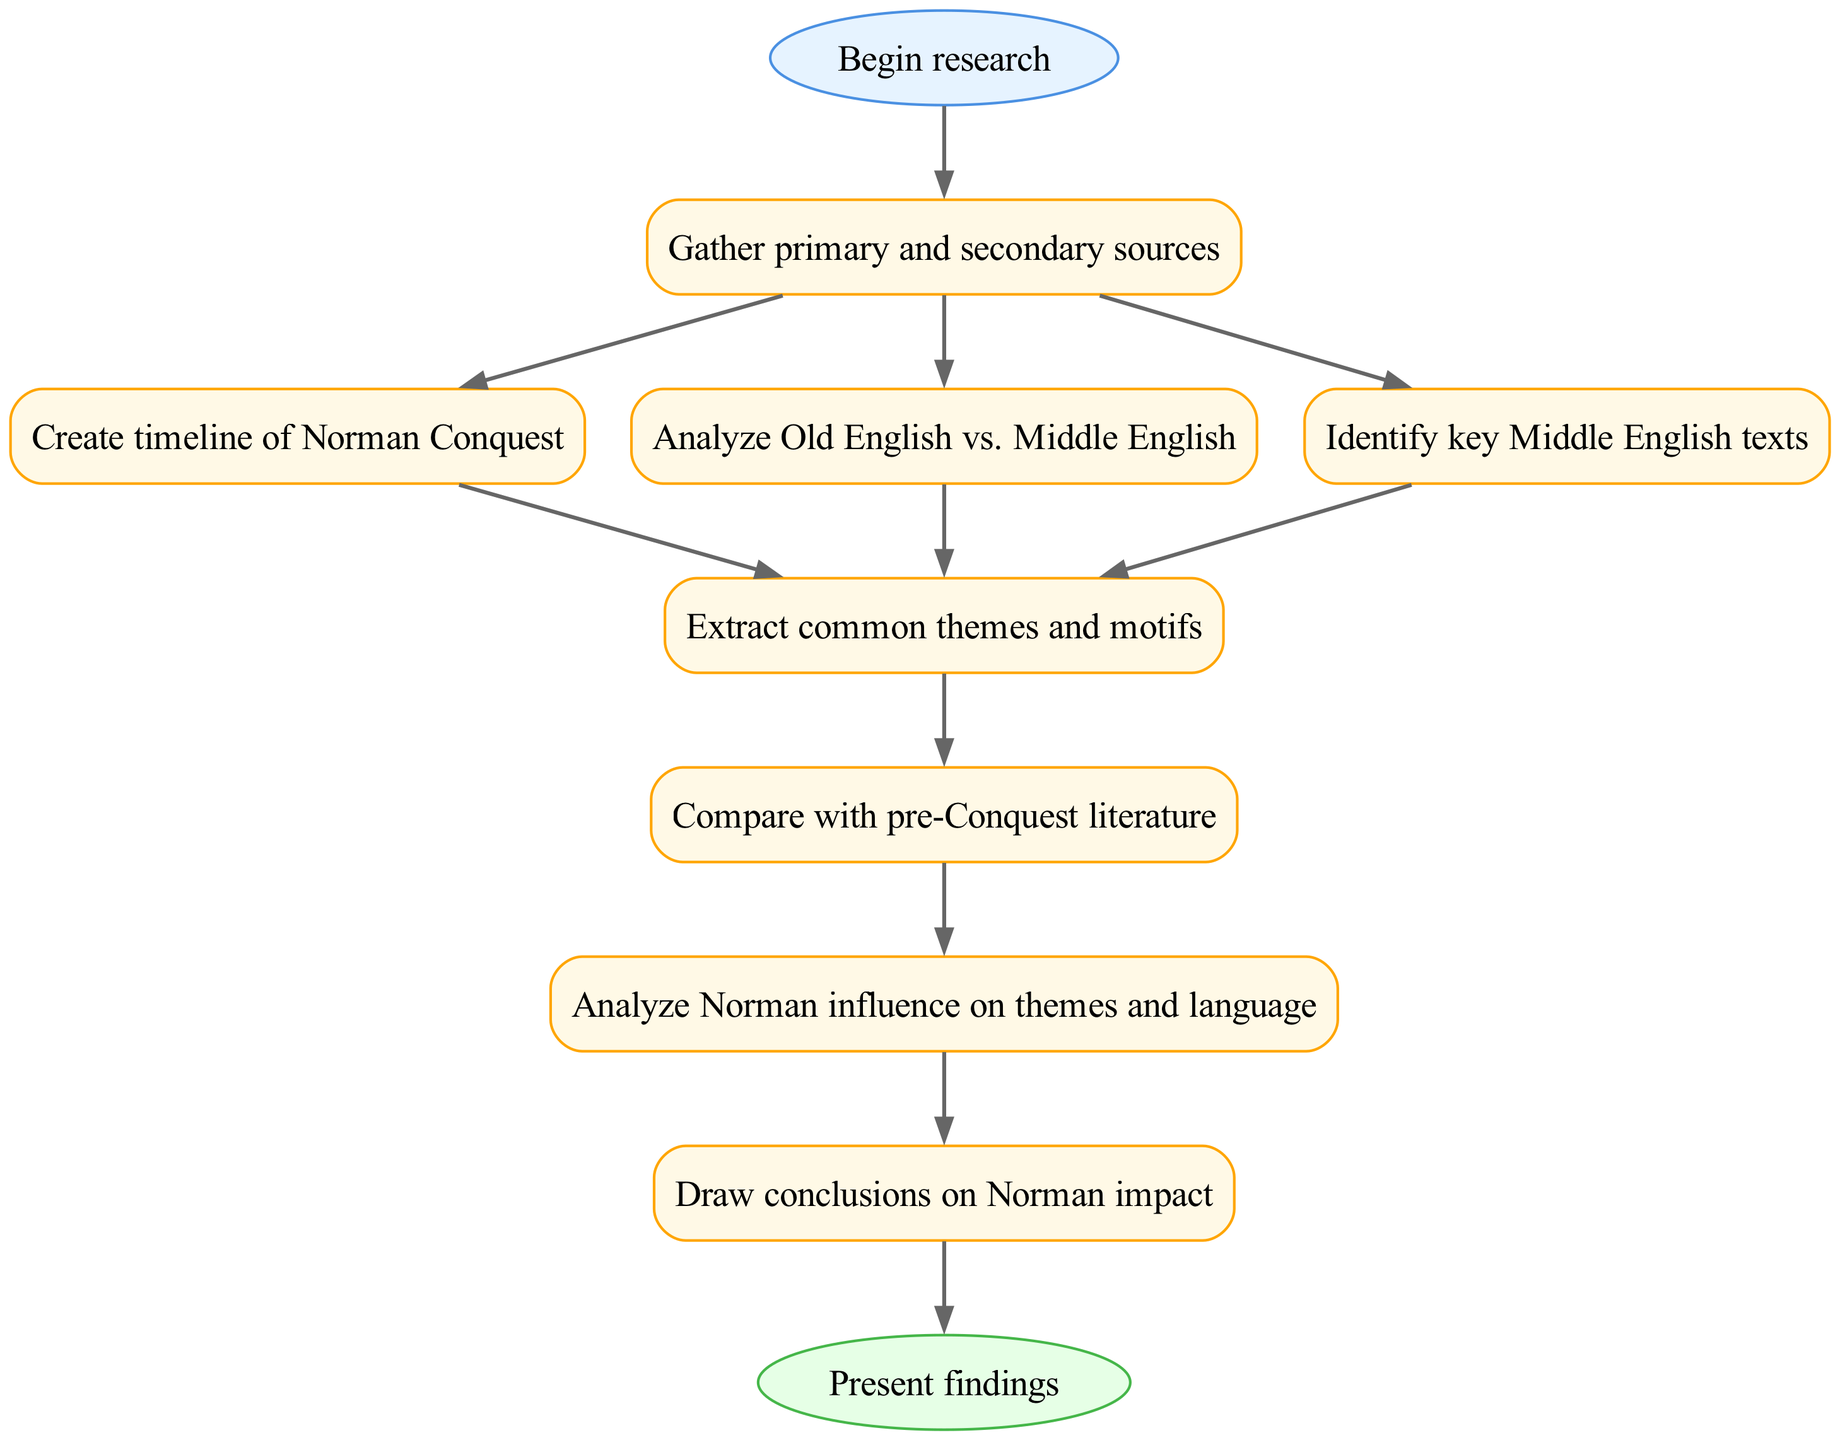What is the first step in the research workflow? The diagram indicates that the first step is labeled "Begin research."
Answer: Begin research How many nodes are there in total? By counting all the listed nodes from "Begin research" to "Present findings," there are 10 nodes present in the diagram.
Answer: 10 What is the last step in the research workflow? The last step shown in the diagram is "Present findings."
Answer: Present findings Which node follows "Analyze Norman influence on themes and language"? According to the flow described in the diagram, the node that follows "Analyze Norman influence on themes and language" is "Draw conclusions on Norman impact."
Answer: Draw conclusions on Norman impact How many edges connect to the "Gather primary and secondary sources" node? Examining the edges linked to the "Gather primary and secondary sources" node, there are three edges leading to "Create timeline of Norman Conquest," "Analyze Old English vs. Middle English," and "Identify key Middle English texts."
Answer: 3 What common pathway connects "Extract common themes and motifs" to "Compare with pre-Conquest literature"? The diagram shows that "Extract common themes and motifs" leads to "Compare with pre-Conquest literature" as the next logical step in the workflow.
Answer: Compare with pre-Conquest literature Which node is connected directly to "Create timeline of Norman Conquest"? The node directly connected to "Create timeline of Norman Conquest" is “Extract common themes and motifs.”
Answer: Extract common themes and motifs What is the relationship between "Identify key Middle English texts" and "Extract common themes and motifs"? "Identify key Middle English texts" contributes to "Extract common themes and motifs" as each text can provide themes for analysis, indicating their direct relationship in the workflow.
Answer: Contributes to What node precedes "Draw conclusions on Norman impact"? The node that precedes "Draw conclusions on Norman impact" in the sequence of the diagram is "Analyze Norman influence on themes and language."
Answer: Analyze Norman influence on themes and language 